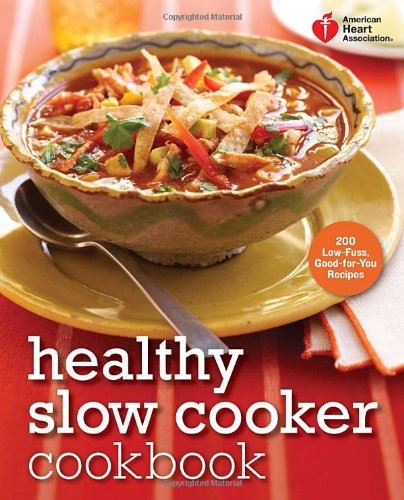Is this book related to Literature & Fiction? No, this book does not delve into literature or fictional writing; instead, it is a highly factual and practical guide to healthy eating using a slow cooker. 